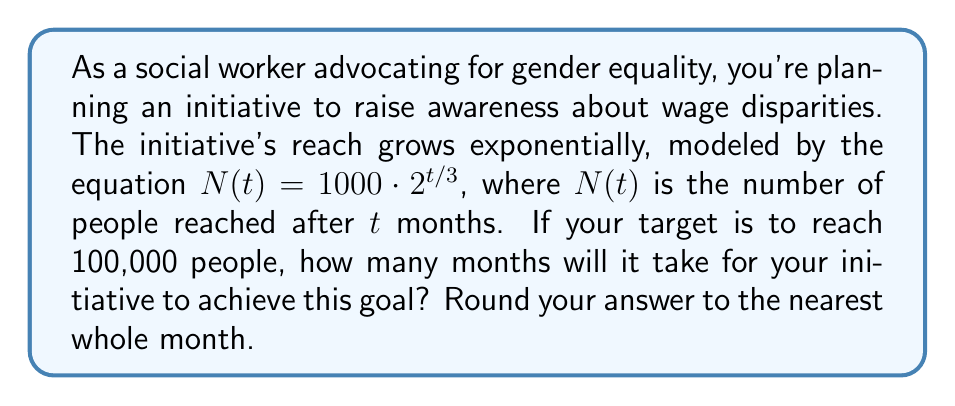Give your solution to this math problem. To solve this problem, we'll use logarithms to isolate the time variable $t$. Let's approach this step-by-step:

1) We start with the given equation: $N(t) = 1000 \cdot 2^{t/3}$

2) We want to find $t$ when $N(t) = 100,000$. So, let's substitute this:

   $100,000 = 1000 \cdot 2^{t/3}$

3) Divide both sides by 1000:

   $100 = 2^{t/3}$

4) Now, we can apply the logarithm (base 2) to both sides:

   $\log_2(100) = \log_2(2^{t/3})$

5) Using the logarithm property $\log_a(a^x) = x$, we get:

   $\log_2(100) = t/3$

6) Multiply both sides by 3:

   $3\log_2(100) = t$

7) Calculate $\log_2(100)$:
   
   $\log_2(100) = \frac{\log(100)}{\log(2)} \approx 6.6439$

8) Therefore:

   $t = 3 \cdot 6.6439 \approx 19.9317$ months

9) Rounding to the nearest whole month:

   $t \approx 20$ months
Answer: 20 months 